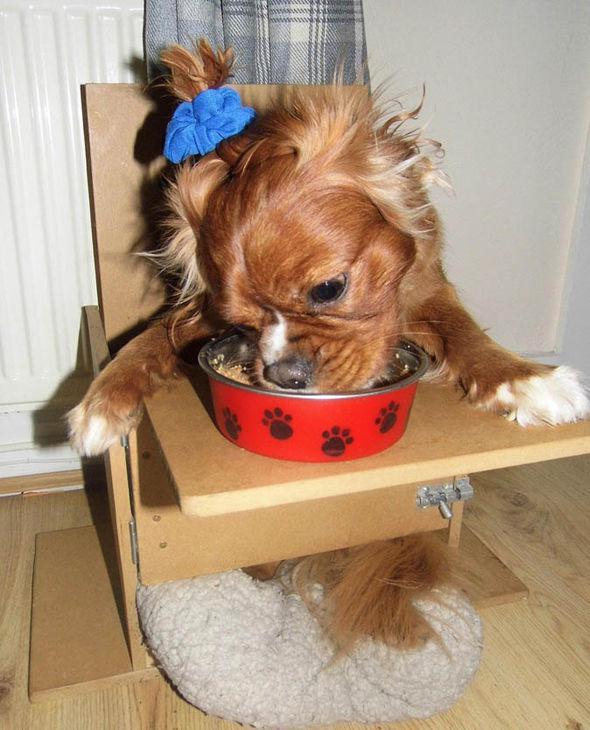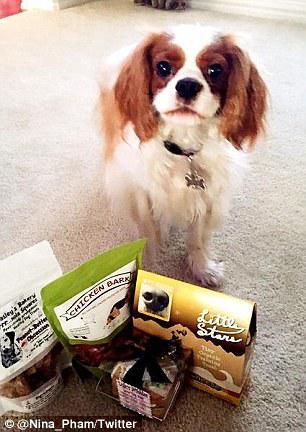The first image is the image on the left, the second image is the image on the right. Given the left and right images, does the statement "Two or more dogs are being held by one or more humans in one of the images." hold true? Answer yes or no. No. The first image is the image on the left, the second image is the image on the right. Given the left and right images, does the statement "There are two dogs." hold true? Answer yes or no. Yes. 